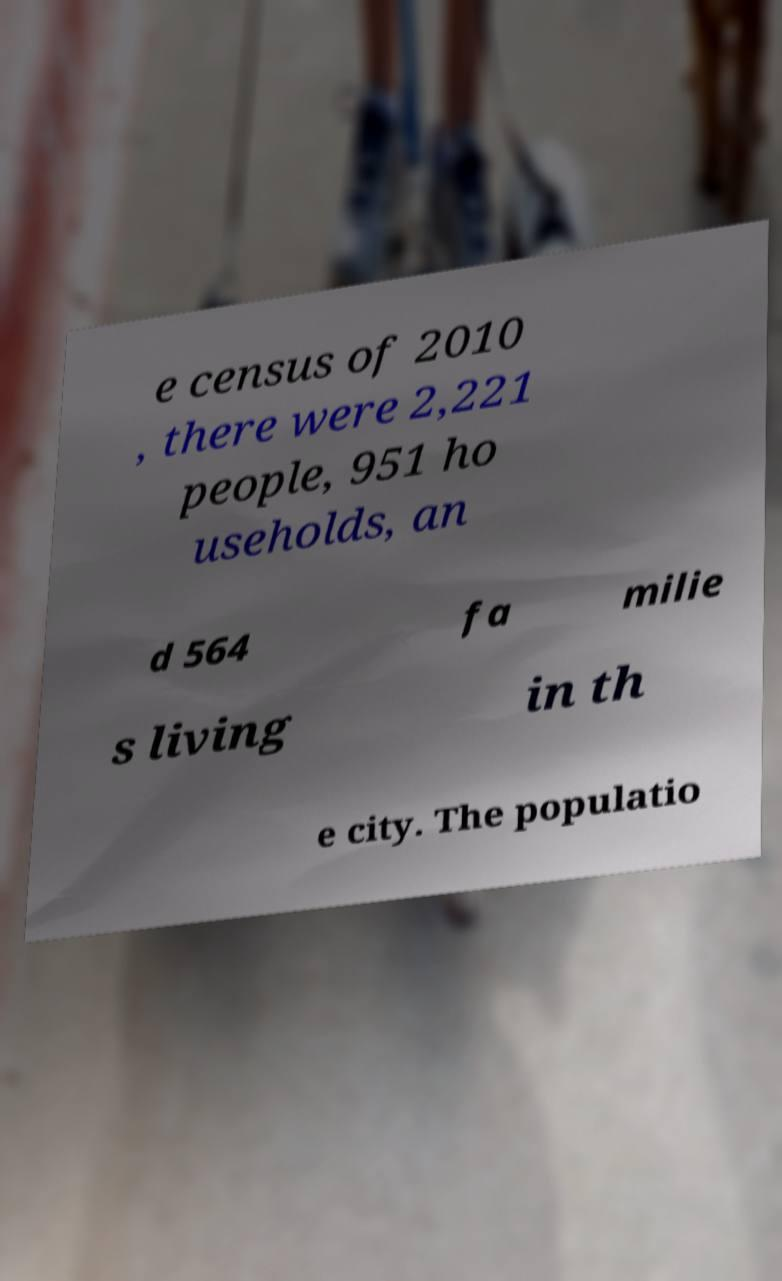For documentation purposes, I need the text within this image transcribed. Could you provide that? e census of 2010 , there were 2,221 people, 951 ho useholds, an d 564 fa milie s living in th e city. The populatio 